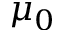<formula> <loc_0><loc_0><loc_500><loc_500>\mu _ { 0 }</formula> 